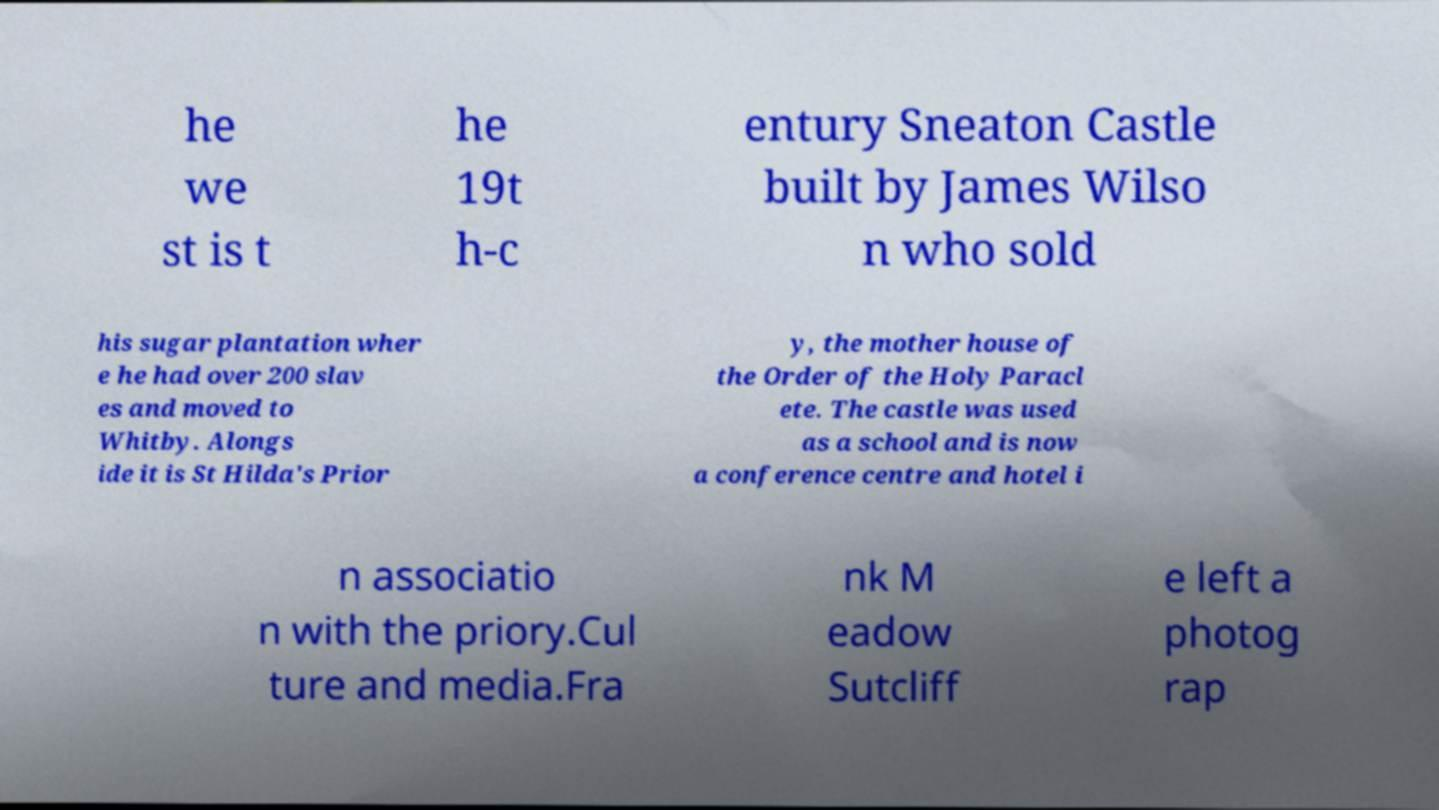For documentation purposes, I need the text within this image transcribed. Could you provide that? he we st is t he 19t h-c entury Sneaton Castle built by James Wilso n who sold his sugar plantation wher e he had over 200 slav es and moved to Whitby. Alongs ide it is St Hilda's Prior y, the mother house of the Order of the Holy Paracl ete. The castle was used as a school and is now a conference centre and hotel i n associatio n with the priory.Cul ture and media.Fra nk M eadow Sutcliff e left a photog rap 